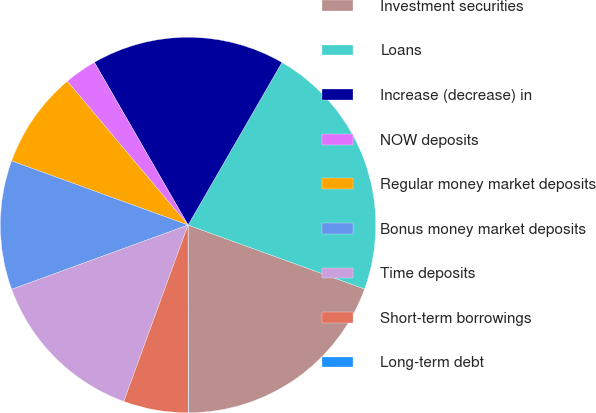<chart> <loc_0><loc_0><loc_500><loc_500><pie_chart><fcel>Investment securities<fcel>Loans<fcel>Increase (decrease) in<fcel>NOW deposits<fcel>Regular money market deposits<fcel>Bonus money market deposits<fcel>Time deposits<fcel>Short-term borrowings<fcel>Long-term debt<nl><fcel>19.43%<fcel>22.2%<fcel>16.65%<fcel>2.8%<fcel>8.34%<fcel>11.11%<fcel>13.88%<fcel>5.57%<fcel>0.03%<nl></chart> 